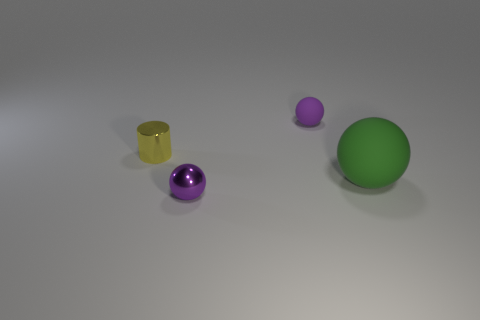There is a tiny object that is both behind the shiny ball and to the right of the yellow shiny thing; what is its material?
Provide a succinct answer. Rubber. There is a matte sphere that is the same color as the tiny metallic ball; what is its size?
Ensure brevity in your answer.  Small. How many other objects are the same size as the green matte thing?
Keep it short and to the point. 0. What material is the object that is right of the small purple rubber ball?
Make the answer very short. Rubber. Is the green matte thing the same shape as the purple metallic object?
Provide a succinct answer. Yes. How many other things are the same shape as the yellow thing?
Your response must be concise. 0. The thing on the right side of the tiny matte thing is what color?
Offer a very short reply. Green. Is the yellow metal cylinder the same size as the metal ball?
Offer a very short reply. Yes. What material is the green object in front of the tiny thing on the right side of the small metal ball?
Ensure brevity in your answer.  Rubber. What number of small matte spheres are the same color as the tiny metal sphere?
Offer a very short reply. 1. 